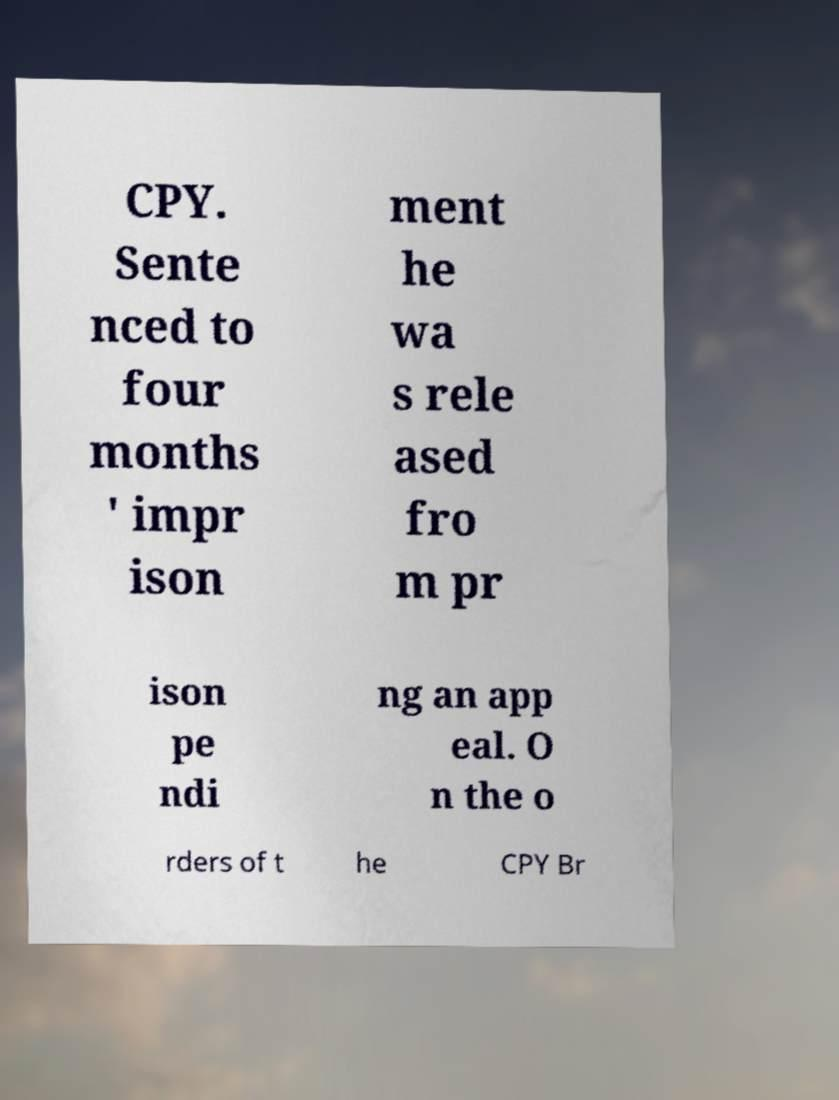For documentation purposes, I need the text within this image transcribed. Could you provide that? CPY. Sente nced to four months ' impr ison ment he wa s rele ased fro m pr ison pe ndi ng an app eal. O n the o rders of t he CPY Br 